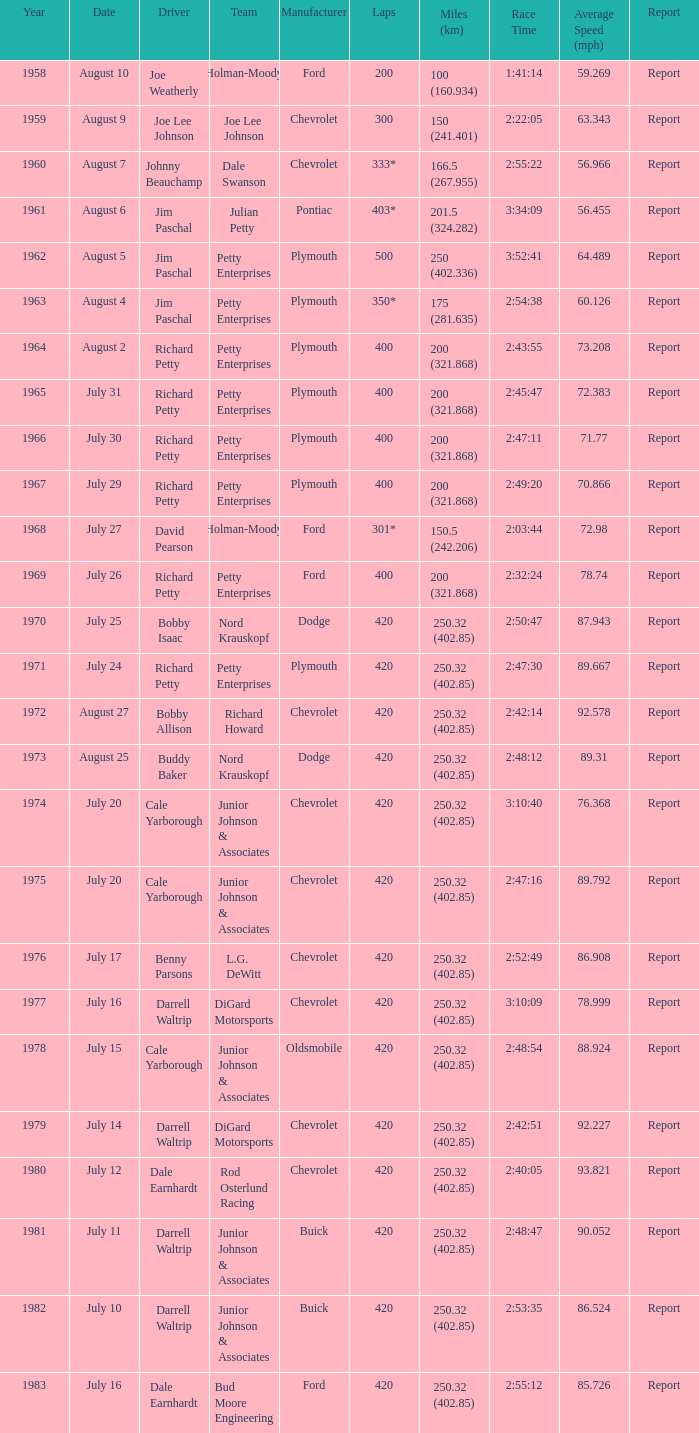What date was the race in 1968 run on? July 27. 